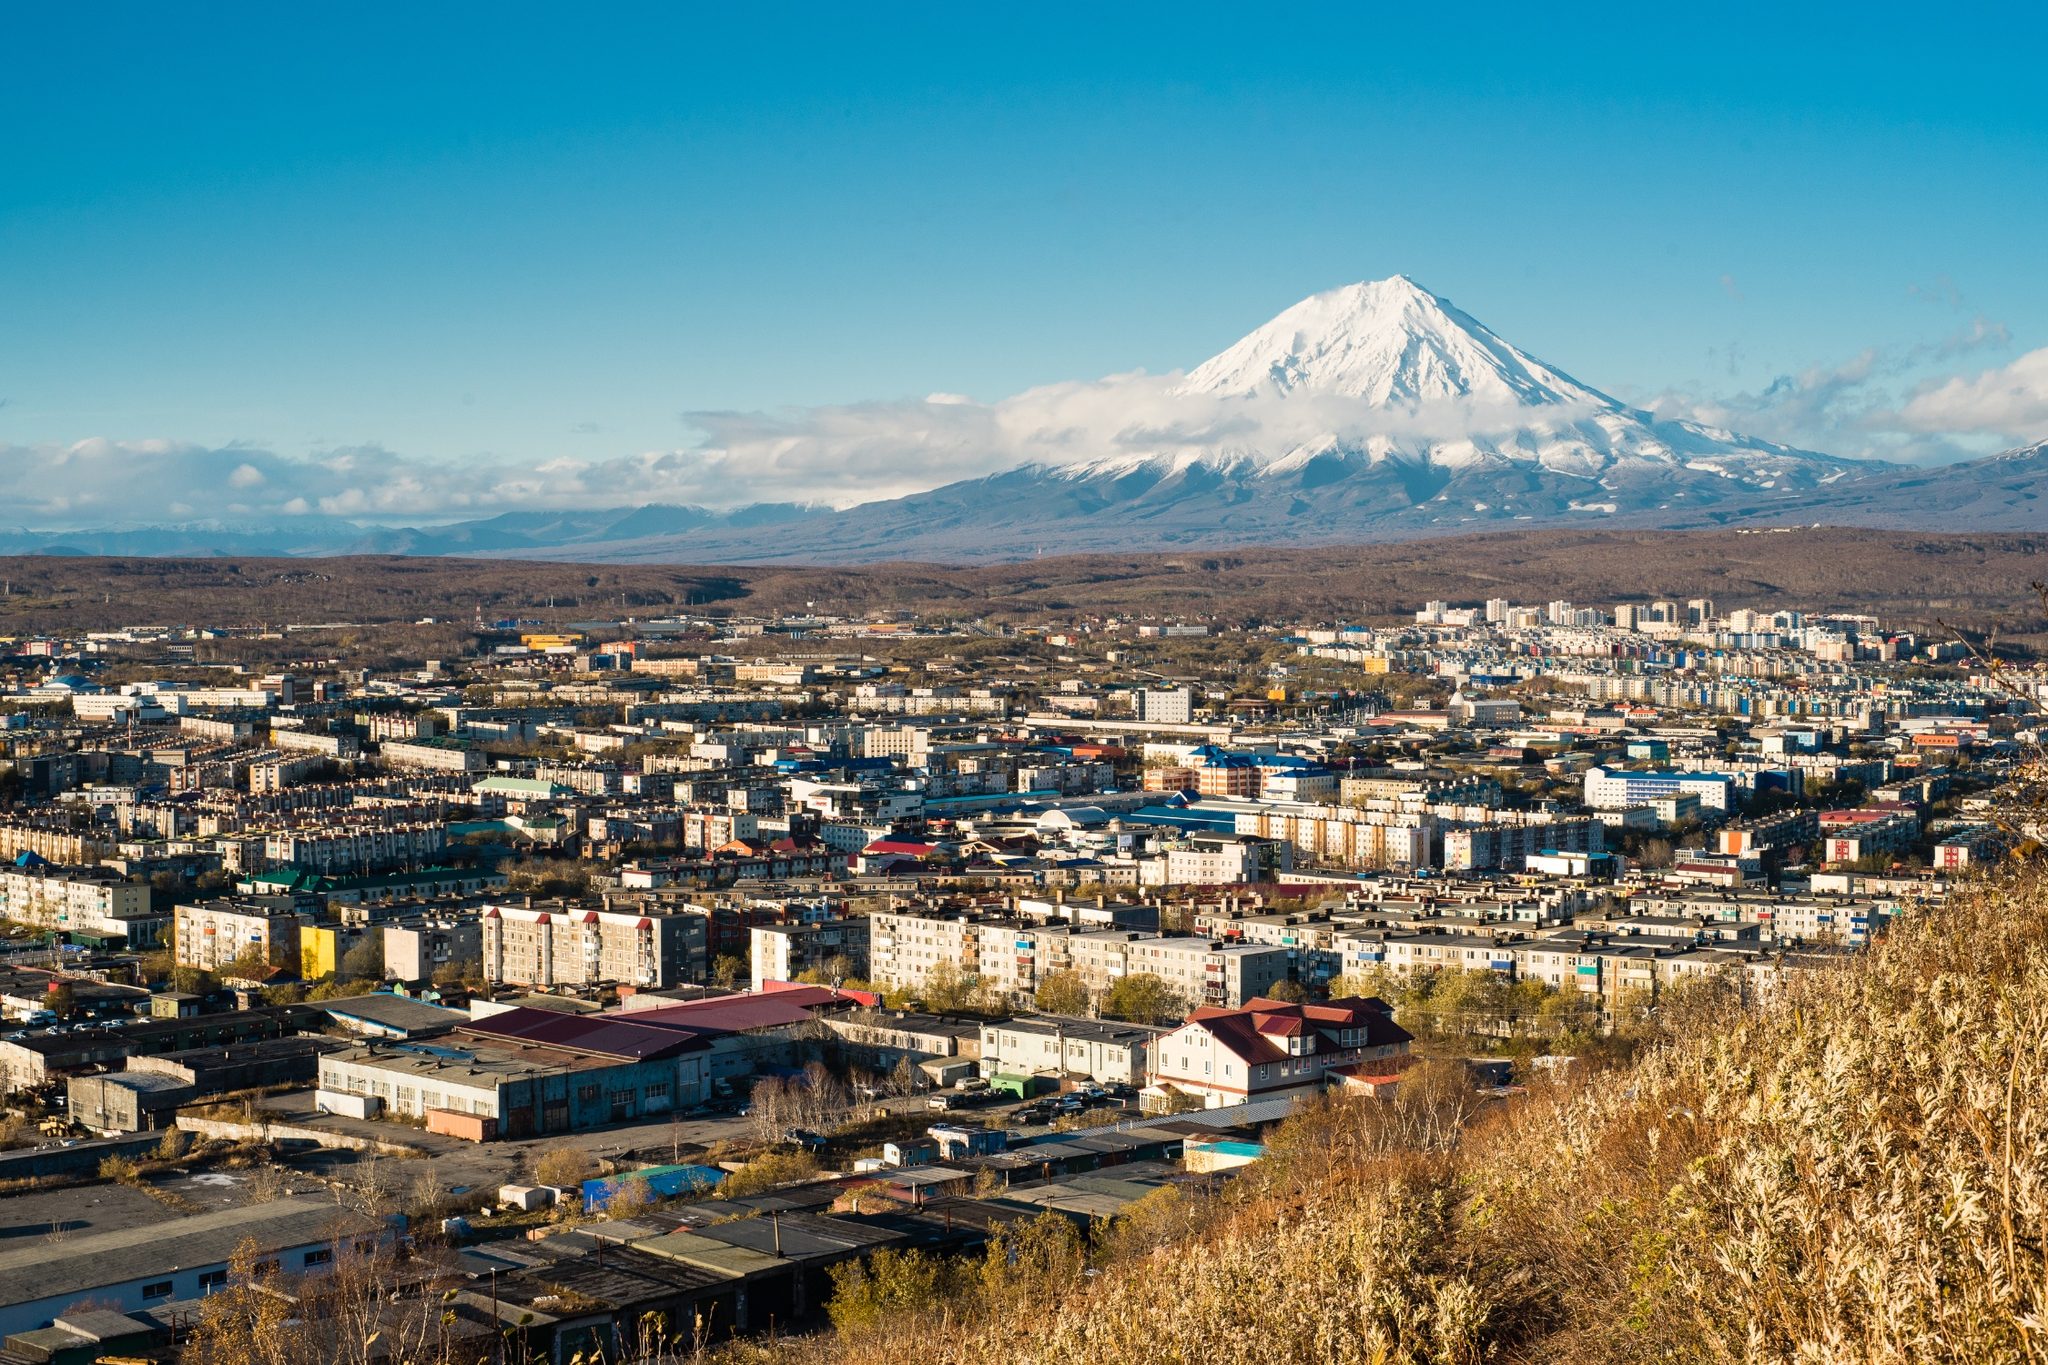How might climate change impact this region, particularly with reference to the volcano? Climate change could have significant impacts on the region surrounding Petropavlovsk-Kamchatsky, particularly regarding the Koryaksky volcano. Rising global temperatures and changing weather patterns could alter the snowfall and ice melt cycles on the volcano, potentially increasing the frequency and intensity of volcanic and seismic activities due to shifts in pressure dynamics. Melting glaciers could contribute to more erosive processes, impacting the stability of the volcanic slopes and increasing the risk of landslides or debris flows. Additionally, changes in precipitation patterns might affect the surrounding ecosystems, impacting local flora and fauna, and potentially disrupting the balance of the environment. The local population might face more frequent natural hazards, necessitating improved disaster preparedness and resilience strategies to adapt to the evolving climatic conditions. 